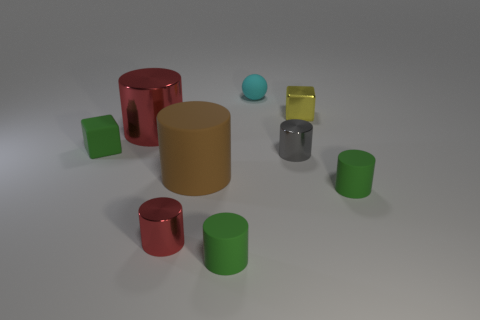What number of other things are there of the same color as the big metallic thing?
Offer a very short reply. 1. What size is the yellow metal block?
Your response must be concise. Small. Is the number of gray cylinders to the left of the brown matte object greater than the number of balls that are behind the small cyan object?
Your response must be concise. No. How many green things are behind the green matte cylinder that is right of the small cyan thing?
Make the answer very short. 1. Does the green thing on the right side of the tiny cyan thing have the same shape as the large red thing?
Provide a succinct answer. Yes. There is a gray thing that is the same shape as the tiny red shiny object; what is its material?
Make the answer very short. Metal. What number of yellow cubes have the same size as the sphere?
Keep it short and to the point. 1. There is a tiny shiny object that is on the right side of the sphere and in front of the yellow block; what is its color?
Offer a very short reply. Gray. Is the number of small gray metallic cylinders less than the number of red metal objects?
Ensure brevity in your answer.  Yes. There is a big shiny cylinder; is its color the same as the tiny matte cylinder that is to the left of the yellow metallic object?
Make the answer very short. No. 